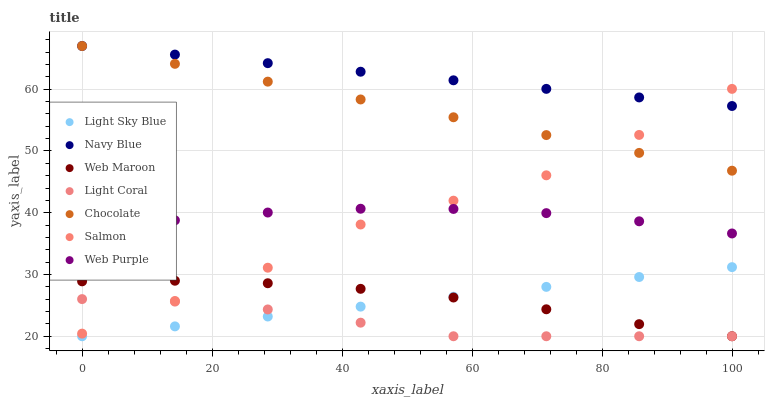Does Light Coral have the minimum area under the curve?
Answer yes or no. Yes. Does Navy Blue have the maximum area under the curve?
Answer yes or no. Yes. Does Web Maroon have the minimum area under the curve?
Answer yes or no. No. Does Web Maroon have the maximum area under the curve?
Answer yes or no. No. Is Light Sky Blue the smoothest?
Answer yes or no. Yes. Is Salmon the roughest?
Answer yes or no. Yes. Is Web Maroon the smoothest?
Answer yes or no. No. Is Web Maroon the roughest?
Answer yes or no. No. Does Web Maroon have the lowest value?
Answer yes or no. Yes. Does Chocolate have the lowest value?
Answer yes or no. No. Does Chocolate have the highest value?
Answer yes or no. Yes. Does Web Maroon have the highest value?
Answer yes or no. No. Is Web Purple less than Navy Blue?
Answer yes or no. Yes. Is Salmon greater than Light Sky Blue?
Answer yes or no. Yes. Does Navy Blue intersect Chocolate?
Answer yes or no. Yes. Is Navy Blue less than Chocolate?
Answer yes or no. No. Is Navy Blue greater than Chocolate?
Answer yes or no. No. Does Web Purple intersect Navy Blue?
Answer yes or no. No. 